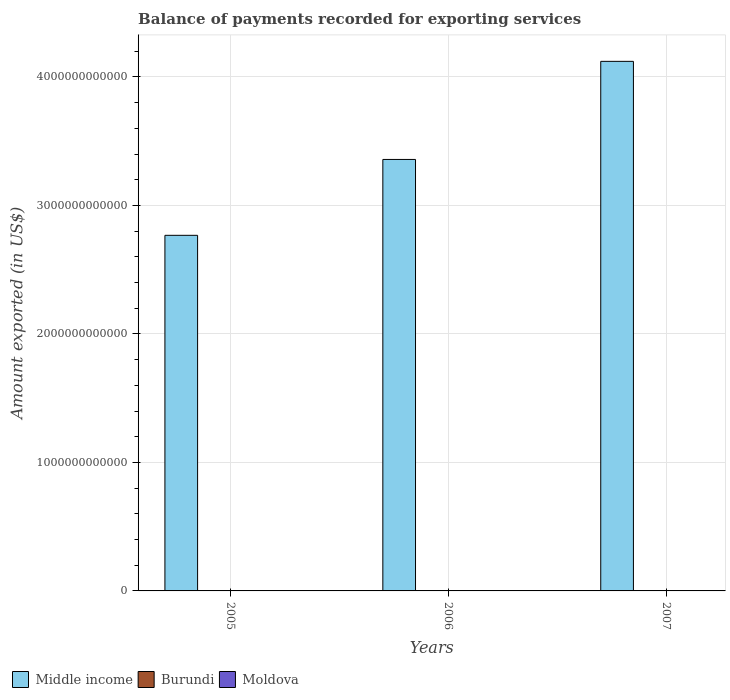Are the number of bars per tick equal to the number of legend labels?
Your response must be concise. Yes. How many bars are there on the 3rd tick from the left?
Offer a terse response. 3. What is the amount exported in Burundi in 2007?
Make the answer very short. 9.83e+07. Across all years, what is the maximum amount exported in Burundi?
Provide a short and direct response. 9.87e+07. Across all years, what is the minimum amount exported in Burundi?
Give a very brief answer. 9.78e+07. In which year was the amount exported in Moldova maximum?
Give a very brief answer. 2007. In which year was the amount exported in Burundi minimum?
Ensure brevity in your answer.  2006. What is the total amount exported in Middle income in the graph?
Keep it short and to the point. 1.02e+13. What is the difference between the amount exported in Middle income in 2005 and that in 2007?
Make the answer very short. -1.35e+12. What is the difference between the amount exported in Burundi in 2007 and the amount exported in Middle income in 2006?
Make the answer very short. -3.36e+12. What is the average amount exported in Middle income per year?
Your answer should be very brief. 3.42e+12. In the year 2005, what is the difference between the amount exported in Moldova and amount exported in Middle income?
Your response must be concise. -2.77e+12. In how many years, is the amount exported in Middle income greater than 3000000000000 US$?
Make the answer very short. 2. What is the ratio of the amount exported in Middle income in 2005 to that in 2006?
Your response must be concise. 0.82. Is the amount exported in Burundi in 2006 less than that in 2007?
Provide a succinct answer. Yes. Is the difference between the amount exported in Moldova in 2006 and 2007 greater than the difference between the amount exported in Middle income in 2006 and 2007?
Provide a short and direct response. Yes. What is the difference between the highest and the second highest amount exported in Middle income?
Make the answer very short. 7.63e+11. What is the difference between the highest and the lowest amount exported in Middle income?
Your answer should be compact. 1.35e+12. In how many years, is the amount exported in Moldova greater than the average amount exported in Moldova taken over all years?
Provide a succinct answer. 1. What does the 2nd bar from the left in 2007 represents?
Offer a terse response. Burundi. How many bars are there?
Ensure brevity in your answer.  9. Are all the bars in the graph horizontal?
Your response must be concise. No. How many years are there in the graph?
Make the answer very short. 3. What is the difference between two consecutive major ticks on the Y-axis?
Your response must be concise. 1.00e+12. Are the values on the major ticks of Y-axis written in scientific E-notation?
Make the answer very short. No. Does the graph contain grids?
Your answer should be very brief. Yes. How are the legend labels stacked?
Keep it short and to the point. Horizontal. What is the title of the graph?
Your answer should be compact. Balance of payments recorded for exporting services. Does "Korea (Democratic)" appear as one of the legend labels in the graph?
Your answer should be compact. No. What is the label or title of the Y-axis?
Your answer should be very brief. Amount exported (in US$). What is the Amount exported (in US$) in Middle income in 2005?
Offer a very short reply. 2.77e+12. What is the Amount exported (in US$) of Burundi in 2005?
Ensure brevity in your answer.  9.87e+07. What is the Amount exported (in US$) in Moldova in 2005?
Your response must be concise. 1.87e+09. What is the Amount exported (in US$) of Middle income in 2006?
Keep it short and to the point. 3.36e+12. What is the Amount exported (in US$) of Burundi in 2006?
Provide a succinct answer. 9.78e+07. What is the Amount exported (in US$) of Moldova in 2006?
Provide a succinct answer. 1.93e+09. What is the Amount exported (in US$) of Middle income in 2007?
Keep it short and to the point. 4.12e+12. What is the Amount exported (in US$) in Burundi in 2007?
Offer a terse response. 9.83e+07. What is the Amount exported (in US$) in Moldova in 2007?
Offer a very short reply. 2.46e+09. Across all years, what is the maximum Amount exported (in US$) of Middle income?
Provide a succinct answer. 4.12e+12. Across all years, what is the maximum Amount exported (in US$) of Burundi?
Give a very brief answer. 9.87e+07. Across all years, what is the maximum Amount exported (in US$) in Moldova?
Offer a very short reply. 2.46e+09. Across all years, what is the minimum Amount exported (in US$) in Middle income?
Provide a short and direct response. 2.77e+12. Across all years, what is the minimum Amount exported (in US$) in Burundi?
Your answer should be very brief. 9.78e+07. Across all years, what is the minimum Amount exported (in US$) in Moldova?
Offer a very short reply. 1.87e+09. What is the total Amount exported (in US$) in Middle income in the graph?
Your answer should be compact. 1.02e+13. What is the total Amount exported (in US$) of Burundi in the graph?
Give a very brief answer. 2.95e+08. What is the total Amount exported (in US$) of Moldova in the graph?
Offer a very short reply. 6.25e+09. What is the difference between the Amount exported (in US$) in Middle income in 2005 and that in 2006?
Your response must be concise. -5.91e+11. What is the difference between the Amount exported (in US$) in Burundi in 2005 and that in 2006?
Give a very brief answer. 9.65e+05. What is the difference between the Amount exported (in US$) of Moldova in 2005 and that in 2006?
Give a very brief answer. -5.65e+07. What is the difference between the Amount exported (in US$) in Middle income in 2005 and that in 2007?
Provide a short and direct response. -1.35e+12. What is the difference between the Amount exported (in US$) in Burundi in 2005 and that in 2007?
Your answer should be compact. 4.44e+05. What is the difference between the Amount exported (in US$) of Moldova in 2005 and that in 2007?
Provide a short and direct response. -5.84e+08. What is the difference between the Amount exported (in US$) in Middle income in 2006 and that in 2007?
Give a very brief answer. -7.63e+11. What is the difference between the Amount exported (in US$) in Burundi in 2006 and that in 2007?
Your answer should be compact. -5.21e+05. What is the difference between the Amount exported (in US$) in Moldova in 2006 and that in 2007?
Ensure brevity in your answer.  -5.28e+08. What is the difference between the Amount exported (in US$) in Middle income in 2005 and the Amount exported (in US$) in Burundi in 2006?
Your response must be concise. 2.77e+12. What is the difference between the Amount exported (in US$) in Middle income in 2005 and the Amount exported (in US$) in Moldova in 2006?
Provide a short and direct response. 2.77e+12. What is the difference between the Amount exported (in US$) in Burundi in 2005 and the Amount exported (in US$) in Moldova in 2006?
Offer a terse response. -1.83e+09. What is the difference between the Amount exported (in US$) in Middle income in 2005 and the Amount exported (in US$) in Burundi in 2007?
Offer a very short reply. 2.77e+12. What is the difference between the Amount exported (in US$) in Middle income in 2005 and the Amount exported (in US$) in Moldova in 2007?
Offer a very short reply. 2.77e+12. What is the difference between the Amount exported (in US$) in Burundi in 2005 and the Amount exported (in US$) in Moldova in 2007?
Offer a terse response. -2.36e+09. What is the difference between the Amount exported (in US$) in Middle income in 2006 and the Amount exported (in US$) in Burundi in 2007?
Provide a short and direct response. 3.36e+12. What is the difference between the Amount exported (in US$) in Middle income in 2006 and the Amount exported (in US$) in Moldova in 2007?
Offer a terse response. 3.36e+12. What is the difference between the Amount exported (in US$) in Burundi in 2006 and the Amount exported (in US$) in Moldova in 2007?
Your answer should be very brief. -2.36e+09. What is the average Amount exported (in US$) of Middle income per year?
Offer a very short reply. 3.42e+12. What is the average Amount exported (in US$) of Burundi per year?
Offer a very short reply. 9.83e+07. What is the average Amount exported (in US$) in Moldova per year?
Make the answer very short. 2.08e+09. In the year 2005, what is the difference between the Amount exported (in US$) of Middle income and Amount exported (in US$) of Burundi?
Ensure brevity in your answer.  2.77e+12. In the year 2005, what is the difference between the Amount exported (in US$) in Middle income and Amount exported (in US$) in Moldova?
Offer a terse response. 2.77e+12. In the year 2005, what is the difference between the Amount exported (in US$) of Burundi and Amount exported (in US$) of Moldova?
Offer a very short reply. -1.77e+09. In the year 2006, what is the difference between the Amount exported (in US$) of Middle income and Amount exported (in US$) of Burundi?
Your response must be concise. 3.36e+12. In the year 2006, what is the difference between the Amount exported (in US$) of Middle income and Amount exported (in US$) of Moldova?
Make the answer very short. 3.36e+12. In the year 2006, what is the difference between the Amount exported (in US$) in Burundi and Amount exported (in US$) in Moldova?
Provide a short and direct response. -1.83e+09. In the year 2007, what is the difference between the Amount exported (in US$) of Middle income and Amount exported (in US$) of Burundi?
Provide a short and direct response. 4.12e+12. In the year 2007, what is the difference between the Amount exported (in US$) of Middle income and Amount exported (in US$) of Moldova?
Offer a very short reply. 4.12e+12. In the year 2007, what is the difference between the Amount exported (in US$) of Burundi and Amount exported (in US$) of Moldova?
Make the answer very short. -2.36e+09. What is the ratio of the Amount exported (in US$) in Middle income in 2005 to that in 2006?
Give a very brief answer. 0.82. What is the ratio of the Amount exported (in US$) of Burundi in 2005 to that in 2006?
Offer a terse response. 1.01. What is the ratio of the Amount exported (in US$) of Moldova in 2005 to that in 2006?
Provide a short and direct response. 0.97. What is the ratio of the Amount exported (in US$) of Middle income in 2005 to that in 2007?
Offer a very short reply. 0.67. What is the ratio of the Amount exported (in US$) in Moldova in 2005 to that in 2007?
Give a very brief answer. 0.76. What is the ratio of the Amount exported (in US$) of Middle income in 2006 to that in 2007?
Provide a succinct answer. 0.81. What is the ratio of the Amount exported (in US$) of Moldova in 2006 to that in 2007?
Offer a very short reply. 0.79. What is the difference between the highest and the second highest Amount exported (in US$) of Middle income?
Make the answer very short. 7.63e+11. What is the difference between the highest and the second highest Amount exported (in US$) in Burundi?
Keep it short and to the point. 4.44e+05. What is the difference between the highest and the second highest Amount exported (in US$) of Moldova?
Keep it short and to the point. 5.28e+08. What is the difference between the highest and the lowest Amount exported (in US$) in Middle income?
Your response must be concise. 1.35e+12. What is the difference between the highest and the lowest Amount exported (in US$) in Burundi?
Provide a short and direct response. 9.65e+05. What is the difference between the highest and the lowest Amount exported (in US$) of Moldova?
Offer a very short reply. 5.84e+08. 